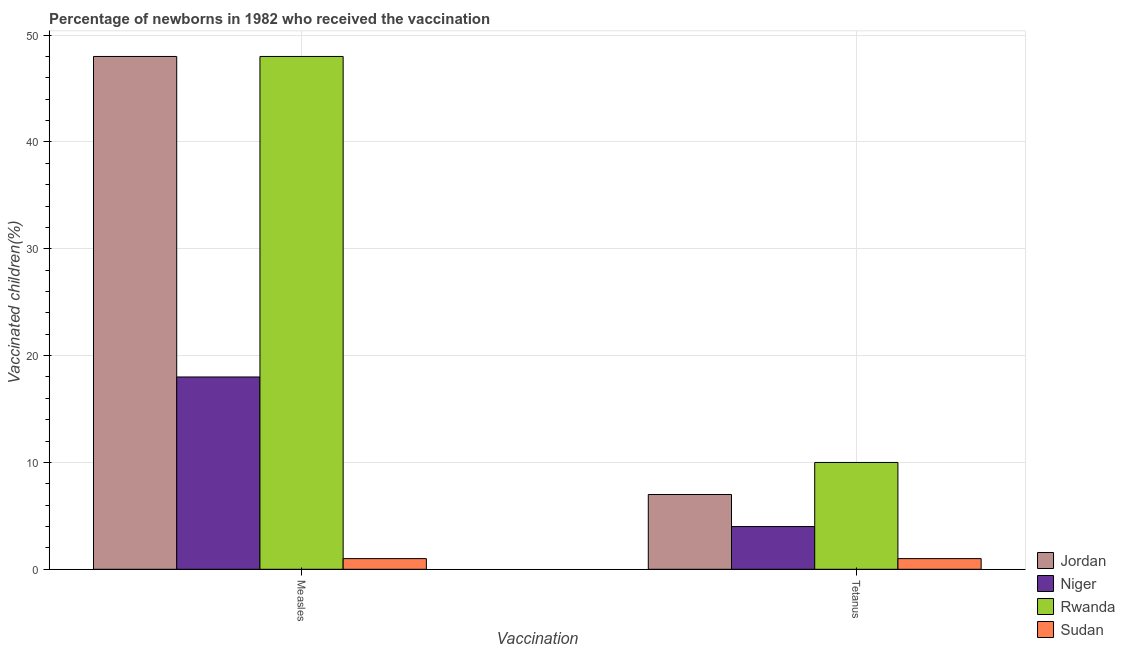How many different coloured bars are there?
Provide a short and direct response. 4. How many groups of bars are there?
Give a very brief answer. 2. Are the number of bars on each tick of the X-axis equal?
Your answer should be very brief. Yes. How many bars are there on the 1st tick from the left?
Your response must be concise. 4. What is the label of the 2nd group of bars from the left?
Provide a short and direct response. Tetanus. What is the percentage of newborns who received vaccination for tetanus in Niger?
Offer a terse response. 4. Across all countries, what is the maximum percentage of newborns who received vaccination for tetanus?
Your answer should be very brief. 10. Across all countries, what is the minimum percentage of newborns who received vaccination for tetanus?
Your response must be concise. 1. In which country was the percentage of newborns who received vaccination for measles maximum?
Keep it short and to the point. Jordan. In which country was the percentage of newborns who received vaccination for measles minimum?
Provide a short and direct response. Sudan. What is the total percentage of newborns who received vaccination for tetanus in the graph?
Make the answer very short. 22. What is the difference between the percentage of newborns who received vaccination for tetanus in Sudan and that in Niger?
Give a very brief answer. -3. What is the difference between the percentage of newborns who received vaccination for measles in Rwanda and the percentage of newborns who received vaccination for tetanus in Sudan?
Offer a terse response. 47. What is the average percentage of newborns who received vaccination for measles per country?
Keep it short and to the point. 28.75. What is the difference between the percentage of newborns who received vaccination for measles and percentage of newborns who received vaccination for tetanus in Rwanda?
Your response must be concise. 38. What is the ratio of the percentage of newborns who received vaccination for tetanus in Rwanda to that in Jordan?
Your response must be concise. 1.43. Is the percentage of newborns who received vaccination for tetanus in Sudan less than that in Rwanda?
Offer a very short reply. Yes. What does the 3rd bar from the left in Measles represents?
Provide a succinct answer. Rwanda. What does the 1st bar from the right in Tetanus represents?
Keep it short and to the point. Sudan. Are all the bars in the graph horizontal?
Your answer should be very brief. No. How many countries are there in the graph?
Provide a succinct answer. 4. What is the difference between two consecutive major ticks on the Y-axis?
Offer a very short reply. 10. Does the graph contain any zero values?
Provide a short and direct response. No. Does the graph contain grids?
Your answer should be compact. Yes. How many legend labels are there?
Keep it short and to the point. 4. What is the title of the graph?
Provide a short and direct response. Percentage of newborns in 1982 who received the vaccination. Does "Costa Rica" appear as one of the legend labels in the graph?
Offer a terse response. No. What is the label or title of the X-axis?
Make the answer very short. Vaccination. What is the label or title of the Y-axis?
Offer a terse response. Vaccinated children(%)
. What is the Vaccinated children(%)
 of Jordan in Measles?
Offer a very short reply. 48. What is the Vaccinated children(%)
 of Niger in Measles?
Provide a succinct answer. 18. What is the Vaccinated children(%)
 in Jordan in Tetanus?
Provide a short and direct response. 7. What is the Vaccinated children(%)
 in Niger in Tetanus?
Offer a very short reply. 4. What is the Vaccinated children(%)
 of Rwanda in Tetanus?
Your response must be concise. 10. What is the Vaccinated children(%)
 in Sudan in Tetanus?
Offer a very short reply. 1. Across all Vaccination, what is the maximum Vaccinated children(%)
 in Rwanda?
Offer a terse response. 48. Across all Vaccination, what is the minimum Vaccinated children(%)
 in Jordan?
Your response must be concise. 7. Across all Vaccination, what is the minimum Vaccinated children(%)
 of Rwanda?
Provide a short and direct response. 10. What is the total Vaccinated children(%)
 in Jordan in the graph?
Offer a terse response. 55. What is the total Vaccinated children(%)
 of Niger in the graph?
Your answer should be very brief. 22. What is the total Vaccinated children(%)
 of Rwanda in the graph?
Offer a terse response. 58. What is the difference between the Vaccinated children(%)
 in Jordan in Measles and that in Tetanus?
Offer a terse response. 41. What is the difference between the Vaccinated children(%)
 in Rwanda in Measles and that in Tetanus?
Ensure brevity in your answer.  38. What is the difference between the Vaccinated children(%)
 in Sudan in Measles and that in Tetanus?
Ensure brevity in your answer.  0. What is the difference between the Vaccinated children(%)
 in Niger in Measles and the Vaccinated children(%)
 in Rwanda in Tetanus?
Make the answer very short. 8. What is the average Vaccinated children(%)
 of Jordan per Vaccination?
Your answer should be very brief. 27.5. What is the average Vaccinated children(%)
 in Rwanda per Vaccination?
Offer a very short reply. 29. What is the difference between the Vaccinated children(%)
 in Jordan and Vaccinated children(%)
 in Niger in Measles?
Ensure brevity in your answer.  30. What is the difference between the Vaccinated children(%)
 in Jordan and Vaccinated children(%)
 in Rwanda in Measles?
Offer a very short reply. 0. What is the difference between the Vaccinated children(%)
 of Niger and Vaccinated children(%)
 of Rwanda in Measles?
Provide a succinct answer. -30. What is the difference between the Vaccinated children(%)
 in Niger and Vaccinated children(%)
 in Sudan in Measles?
Keep it short and to the point. 17. What is the difference between the Vaccinated children(%)
 in Rwanda and Vaccinated children(%)
 in Sudan in Measles?
Provide a short and direct response. 47. What is the difference between the Vaccinated children(%)
 of Jordan and Vaccinated children(%)
 of Rwanda in Tetanus?
Your answer should be compact. -3. What is the difference between the Vaccinated children(%)
 of Niger and Vaccinated children(%)
 of Rwanda in Tetanus?
Your answer should be compact. -6. What is the difference between the Vaccinated children(%)
 of Niger and Vaccinated children(%)
 of Sudan in Tetanus?
Offer a very short reply. 3. What is the difference between the Vaccinated children(%)
 of Rwanda and Vaccinated children(%)
 of Sudan in Tetanus?
Your answer should be very brief. 9. What is the ratio of the Vaccinated children(%)
 in Jordan in Measles to that in Tetanus?
Ensure brevity in your answer.  6.86. What is the ratio of the Vaccinated children(%)
 of Rwanda in Measles to that in Tetanus?
Your response must be concise. 4.8. What is the ratio of the Vaccinated children(%)
 of Sudan in Measles to that in Tetanus?
Provide a succinct answer. 1. What is the difference between the highest and the second highest Vaccinated children(%)
 in Niger?
Give a very brief answer. 14. What is the difference between the highest and the lowest Vaccinated children(%)
 of Jordan?
Ensure brevity in your answer.  41. What is the difference between the highest and the lowest Vaccinated children(%)
 in Rwanda?
Provide a short and direct response. 38. 